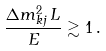<formula> <loc_0><loc_0><loc_500><loc_500>\frac { \Delta { m } ^ { 2 } _ { k j } \, L } { E } \gtrsim 1 \, .</formula> 